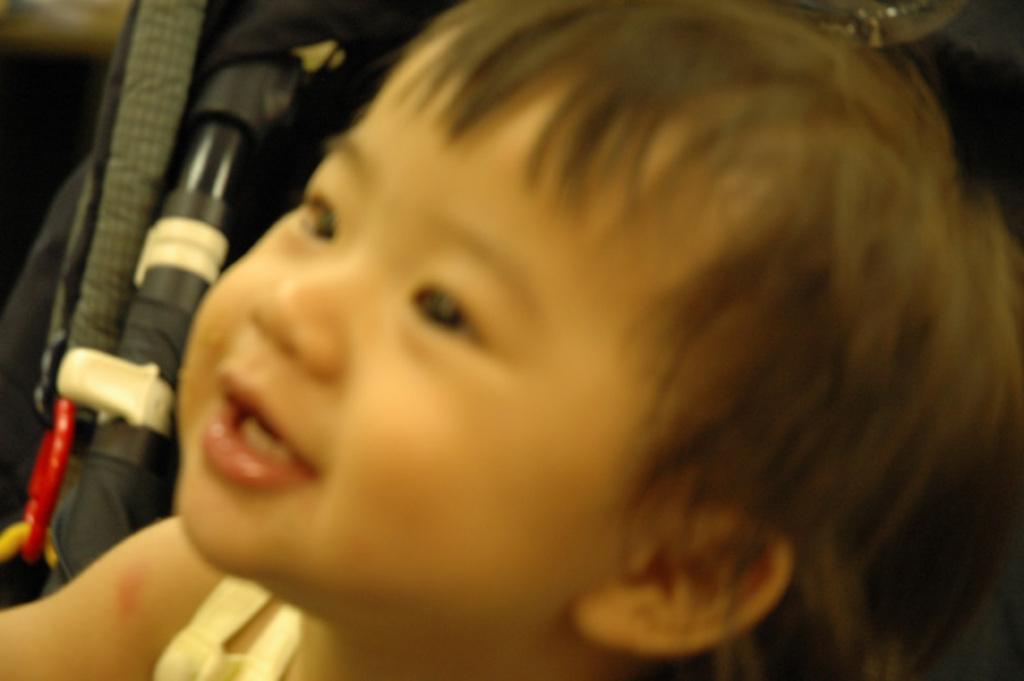Can you describe this image briefly? In this image in the front there is a boy smiling. In the background there is a bag which is black in colour and there is an object which is green and white in colour. 